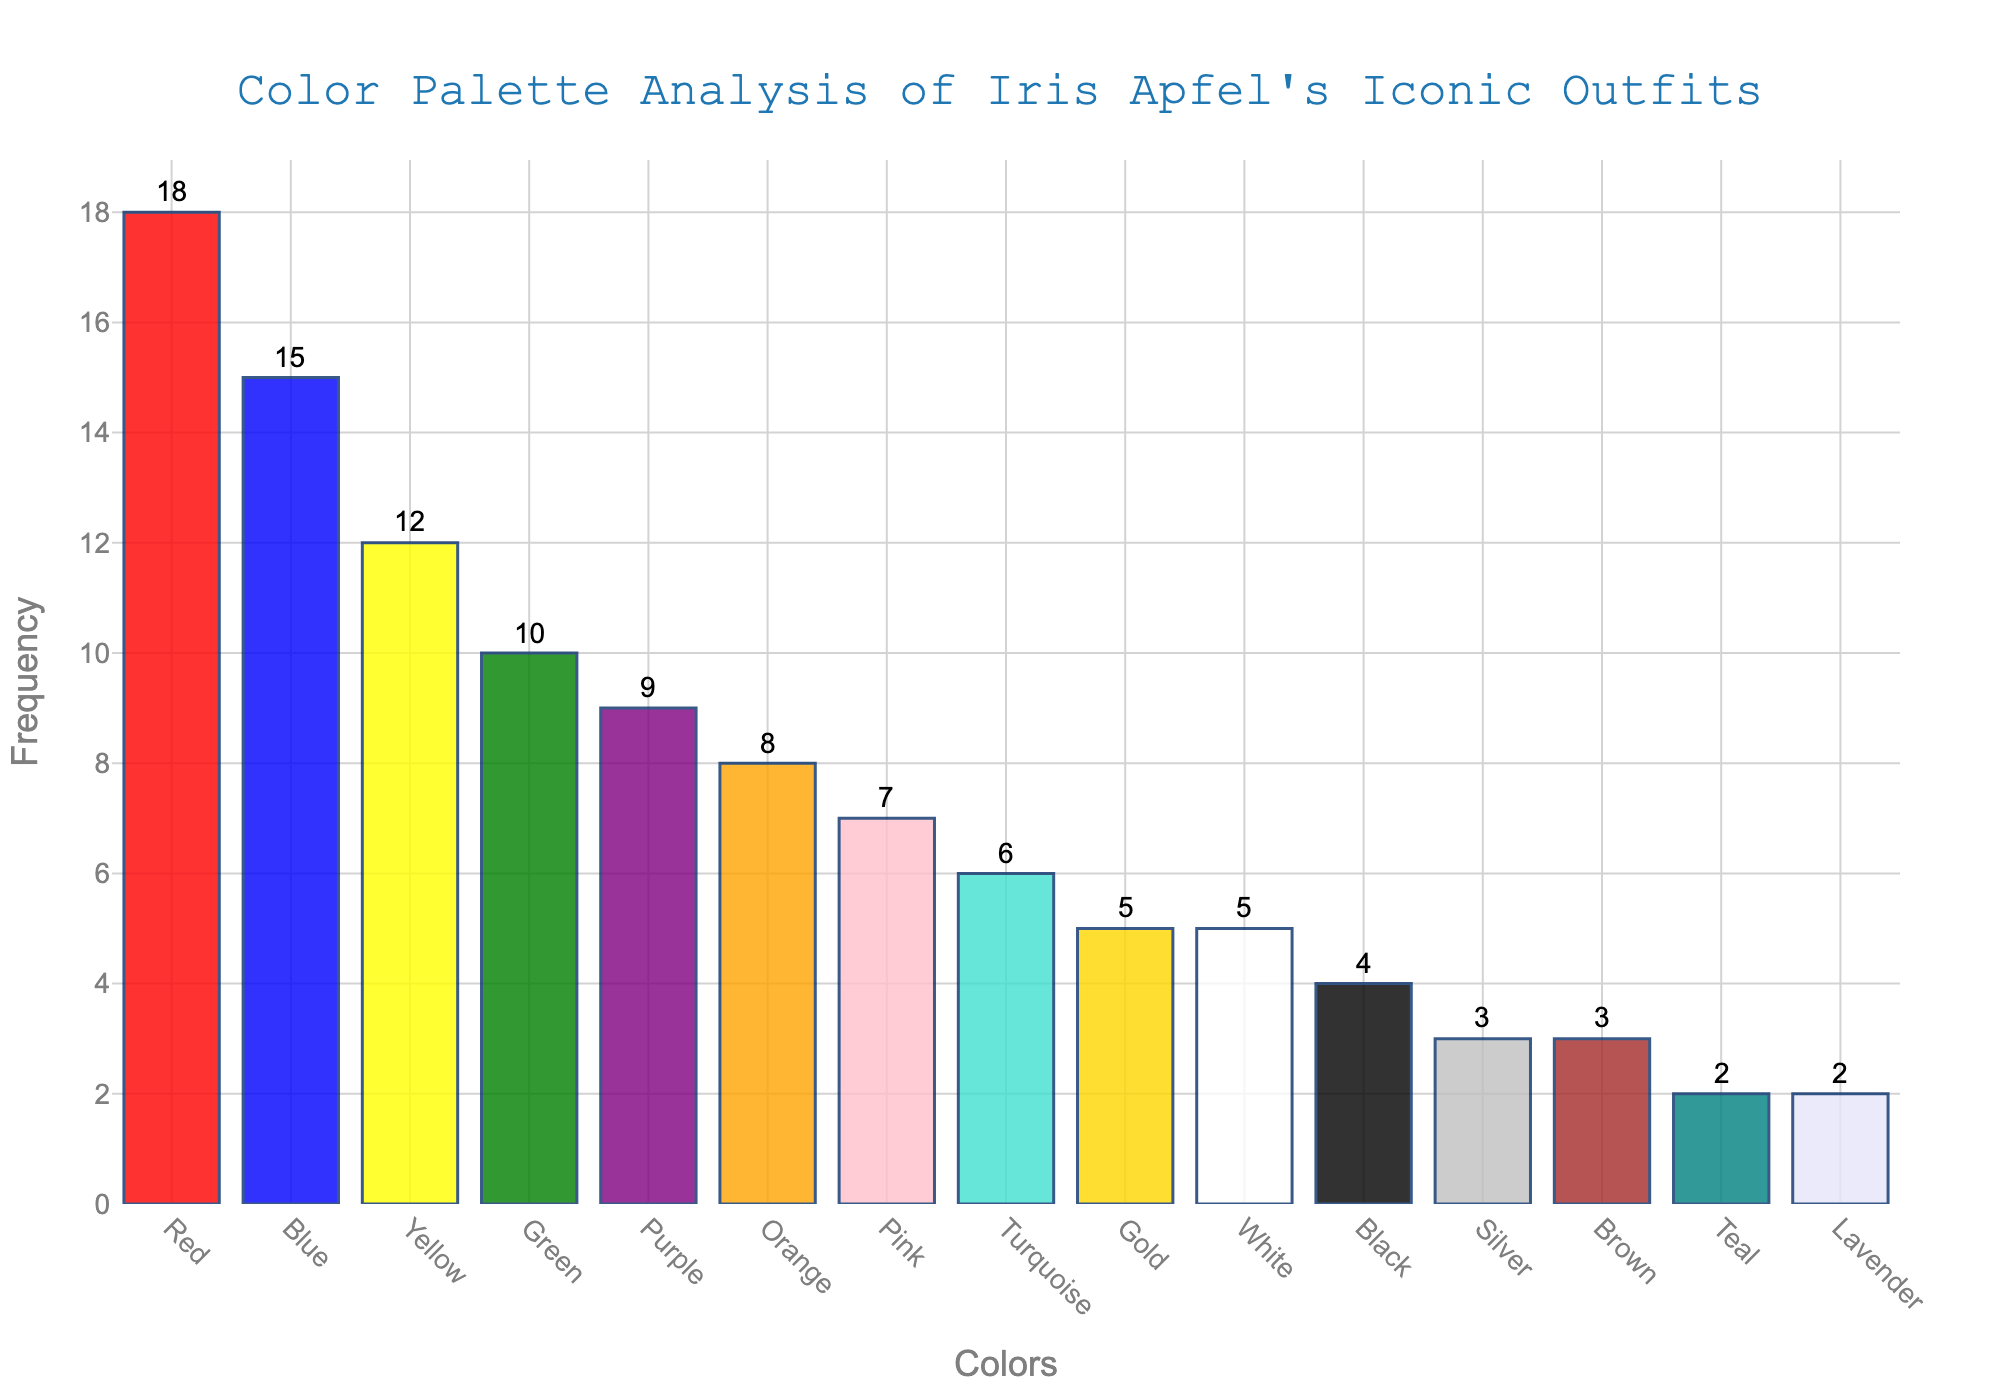What's the most frequently occurring color in Iris Apfel's iconic outfits? The highest bar in the chart represents the color with the highest frequency. Looking at the chart, the height of the bar for "Red" is the tallest.
Answer: Red Which color appears more frequently: Blue or Yellow? Compare the heights of the bars for Blue and Yellow. The bar for Blue is taller than the bar for Yellow, indicating a higher frequency.
Answer: Blue What is the total frequency of the top three most frequent colors? Identify the three tallest bars, which correspond to Red, Blue, and Yellow. Sum their frequencies: 18 (Red) + 15 (Blue) + 12 (Yellow).
Answer: 45 How many colors have a frequency greater than 10? Count the number of bars greater than the 10 frequency mark. The colors Red, Blue, Yellow, and Green have frequencies greater than 10.
Answer: 4 What's the least frequently appearing color in the chart? The shortest bars represent the least frequent colors. Teal and Lavender are equally shortest in height.
Answer: Teal and Lavender How does the frequency of Pink compare to that of Orange? Look at the heights of the bars for Pink and Orange. The bar for Orange is taller than the bar for Pink, indicating a higher frequency for Orange.
Answer: Orange What is the combined frequency of metallic colors (Gold, Silver)? Find the frequencies for Gold and Silver and add them: 5 (Gold) + 3 (Silver).
Answer: 8 Which color ranks fifth in terms of frequency? Sort the bars in descending order of height and identify the fifth one. The fifth tallest bar corresponds to the color Purple.
Answer: Purple Are there any colors with the same frequency? If so, which ones? Observe the bars of the same height. White and Gold both have a frequency of 5. Brown and Silver each have a frequency of 3, and Teal and Lavender each have a frequency of 2.
Answer: White and Gold; Brown and Silver; Teal and Lavender 